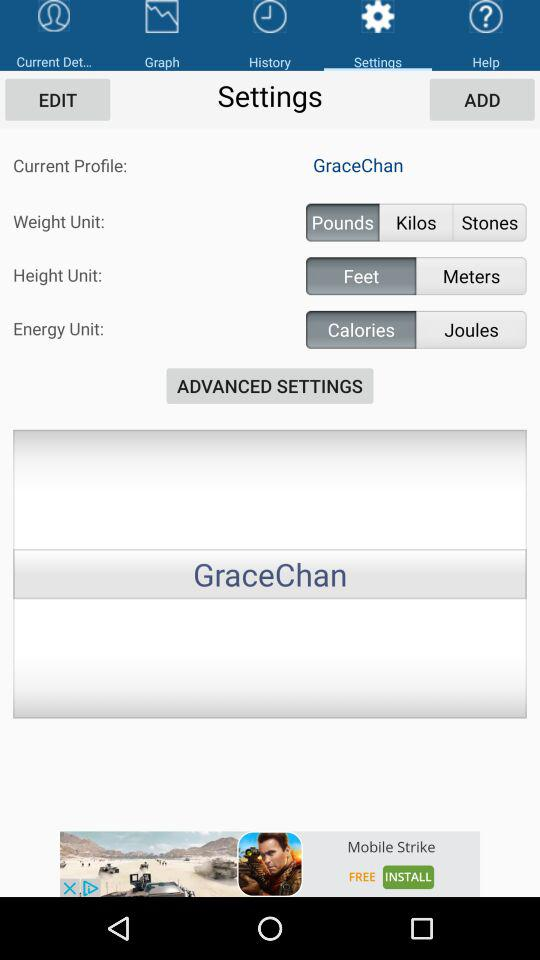Which tab is selected? The selected tab is "Settings". 